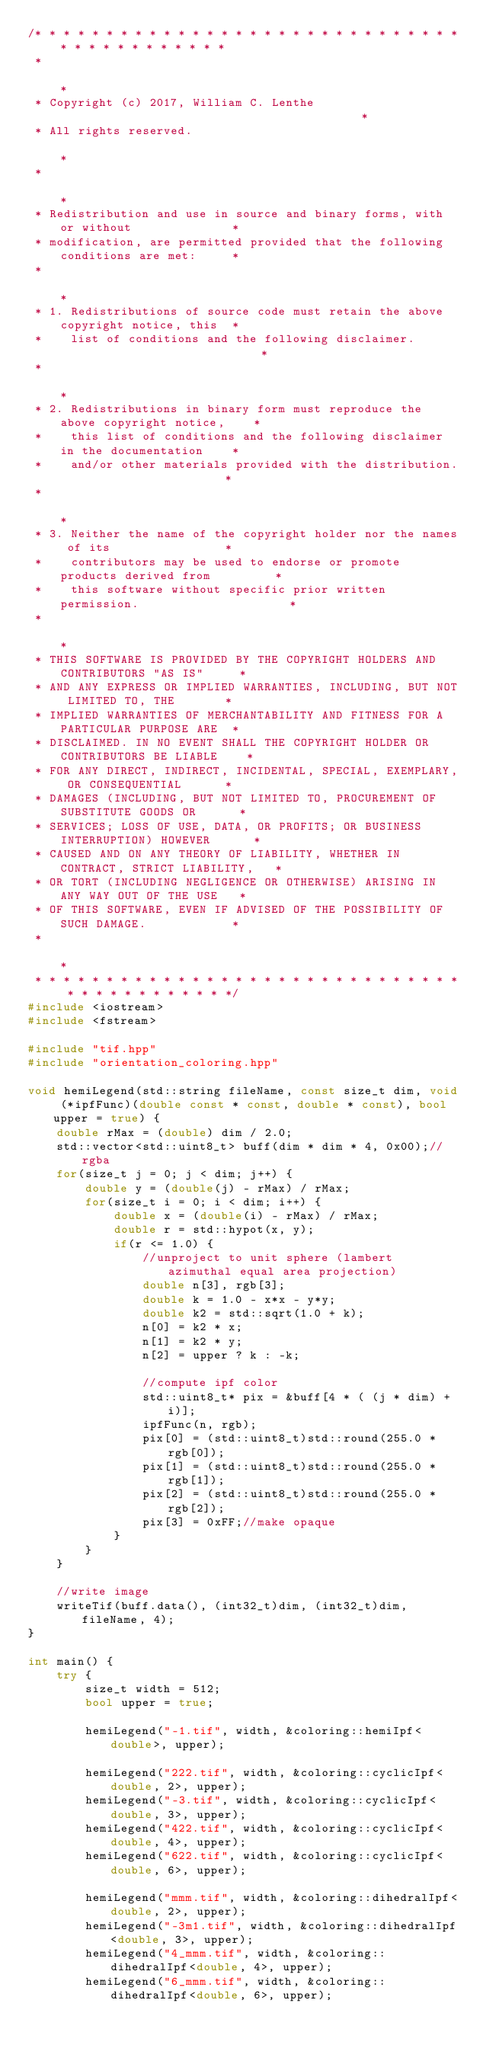<code> <loc_0><loc_0><loc_500><loc_500><_C++_>/* * * * * * * * * * * * * * * * * * * * * * * * * * * * * * * * * * * * * * * * * *
 *                                                                                 *
 * Copyright (c) 2017, William C. Lenthe                                           *
 * All rights reserved.                                                            *
 *                                                                                 *
 * Redistribution and use in source and binary forms, with or without              *
 * modification, are permitted provided that the following conditions are met:     *
 *                                                                                 *
 * 1. Redistributions of source code must retain the above copyright notice, this  *
 *    list of conditions and the following disclaimer.                             *
 *                                                                                 *
 * 2. Redistributions in binary form must reproduce the above copyright notice,    *
 *    this list of conditions and the following disclaimer in the documentation    *
 *    and/or other materials provided with the distribution.                       *
 *                                                                                 *
 * 3. Neither the name of the copyright holder nor the names of its                *
 *    contributors may be used to endorse or promote products derived from         *
 *    this software without specific prior written permission.                     *
 *                                                                                 *
 * THIS SOFTWARE IS PROVIDED BY THE COPYRIGHT HOLDERS AND CONTRIBUTORS "AS IS"     *
 * AND ANY EXPRESS OR IMPLIED WARRANTIES, INCLUDING, BUT NOT LIMITED TO, THE       *
 * IMPLIED WARRANTIES OF MERCHANTABILITY AND FITNESS FOR A PARTICULAR PURPOSE ARE  *
 * DISCLAIMED. IN NO EVENT SHALL THE COPYRIGHT HOLDER OR CONTRIBUTORS BE LIABLE    *
 * FOR ANY DIRECT, INDIRECT, INCIDENTAL, SPECIAL, EXEMPLARY, OR CONSEQUENTIAL      *
 * DAMAGES (INCLUDING, BUT NOT LIMITED TO, PROCUREMENT OF SUBSTITUTE GOODS OR      *
 * SERVICES; LOSS OF USE, DATA, OR PROFITS; OR BUSINESS INTERRUPTION) HOWEVER      *
 * CAUSED AND ON ANY THEORY OF LIABILITY, WHETHER IN CONTRACT, STRICT LIABILITY,   *
 * OR TORT (INCLUDING NEGLIGENCE OR OTHERWISE) ARISING IN ANY WAY OUT OF THE USE   *
 * OF THIS SOFTWARE, EVEN IF ADVISED OF THE POSSIBILITY OF SUCH DAMAGE.            *
 *                                                                                 *
 * * * * * * * * * * * * * * * * * * * * * * * * * * * * * * * * * * * * * * * * * */
#include <iostream>
#include <fstream>

#include "tif.hpp"
#include "orientation_coloring.hpp"

void hemiLegend(std::string fileName, const size_t dim, void (*ipfFunc)(double const * const, double * const), bool upper = true) {
	double rMax = (double) dim / 2.0;
	std::vector<std::uint8_t> buff(dim * dim * 4, 0x00);//rgba
	for(size_t j = 0; j < dim; j++) {
		double y = (double(j) - rMax) / rMax;
		for(size_t i = 0; i < dim; i++) {
			double x = (double(i) - rMax) / rMax;
			double r = std::hypot(x, y);
			if(r <= 1.0) {
				//unproject to unit sphere (lambert azimuthal equal area projection)
				double n[3], rgb[3];
				double k = 1.0 - x*x - y*y;
				double k2 = std::sqrt(1.0 + k);
				n[0] = k2 * x;
				n[1] = k2 * y;
				n[2] = upper ? k : -k;

				//compute ipf color
				std::uint8_t* pix = &buff[4 * ( (j * dim) + i)];
				ipfFunc(n, rgb);
				pix[0] = (std::uint8_t)std::round(255.0 * rgb[0]);
				pix[1] = (std::uint8_t)std::round(255.0 * rgb[1]);
				pix[2] = (std::uint8_t)std::round(255.0 * rgb[2]);
				pix[3] = 0xFF;//make opaque
			}
		}
	}

	//write image
	writeTif(buff.data(), (int32_t)dim, (int32_t)dim, fileName, 4);
}

int main() {
	try {
		size_t width = 512;
		bool upper = true;

		hemiLegend("-1.tif", width, &coloring::hemiIpf<double>, upper);

		hemiLegend("222.tif", width, &coloring::cyclicIpf<double, 2>, upper);
		hemiLegend("-3.tif", width, &coloring::cyclicIpf<double, 3>, upper);
		hemiLegend("422.tif", width, &coloring::cyclicIpf<double, 4>, upper);
		hemiLegend("622.tif", width, &coloring::cyclicIpf<double, 6>, upper);

		hemiLegend("mmm.tif", width, &coloring::dihedralIpf<double, 2>, upper);
		hemiLegend("-3m1.tif", width, &coloring::dihedralIpf<double, 3>, upper);
		hemiLegend("4_mmm.tif", width, &coloring::dihedralIpf<double, 4>, upper);
		hemiLegend("6_mmm.tif", width, &coloring::dihedralIpf<double, 6>, upper);
		</code> 